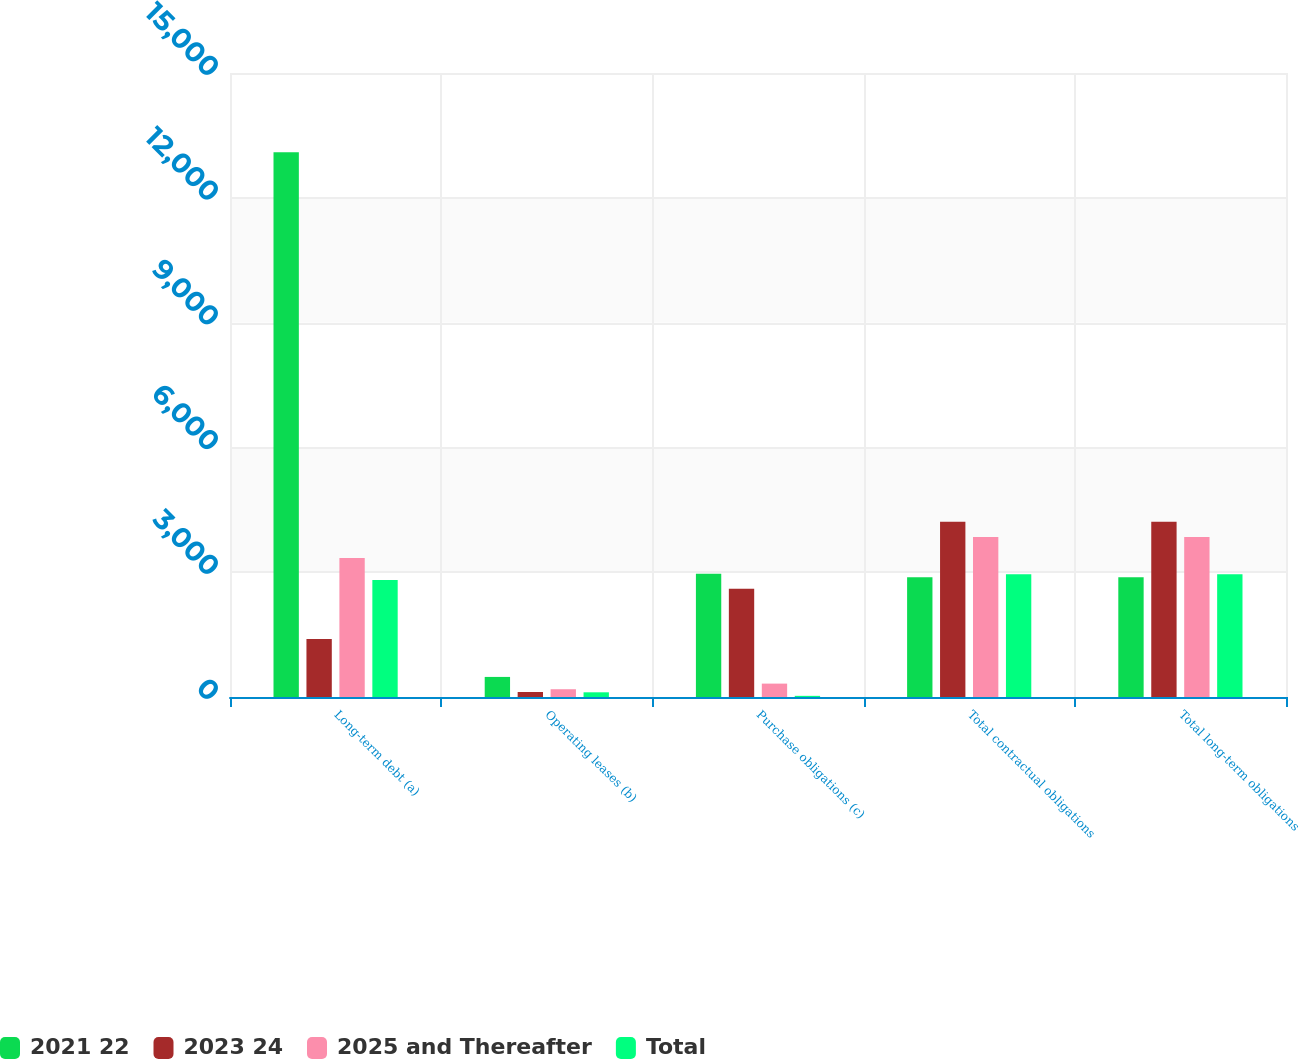Convert chart. <chart><loc_0><loc_0><loc_500><loc_500><stacked_bar_chart><ecel><fcel>Long-term debt (a)<fcel>Operating leases (b)<fcel>Purchase obligations (c)<fcel>Total contractual obligations<fcel>Total long-term obligations<nl><fcel>2021 22<fcel>13093<fcel>482.6<fcel>2961.8<fcel>2880.45<fcel>2880.45<nl><fcel>2023 24<fcel>1396.3<fcel>120<fcel>2605.1<fcel>4214.2<fcel>4214.2<nl><fcel>2025 and Thereafter<fcel>3338.4<fcel>186.7<fcel>321.9<fcel>3847.1<fcel>3847.1<nl><fcel>Total<fcel>2810.2<fcel>112.9<fcel>27.6<fcel>2950.7<fcel>2950.7<nl></chart> 